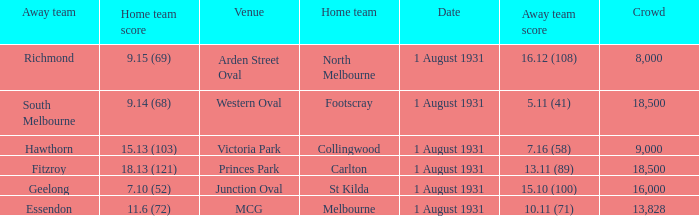What is the home team at the venue mcg? Melbourne. 